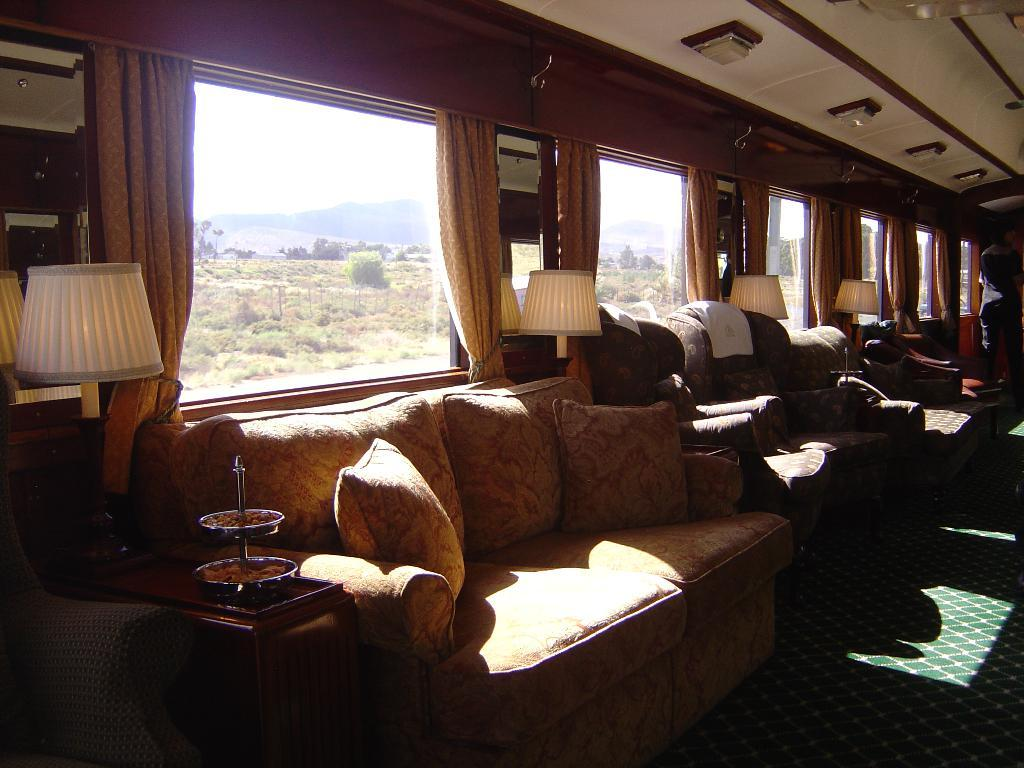What type of space is shown in the image? The image depicts the interior of a room. What can be seen in the room that provides illumination? There are lights in the room. What type of window treatment is present in the room? There are curtains in the room. What type of furniture is present in the room? There are sofas in the room. What type of accessory is present on the sofas? There are pillows in the room. What can be seen in the background of the image? There are trees visible in the background of the image. What type of ornament is hanging from the grip of the sofa in the image? There is no grip or ornament present on the sofa in the image. 